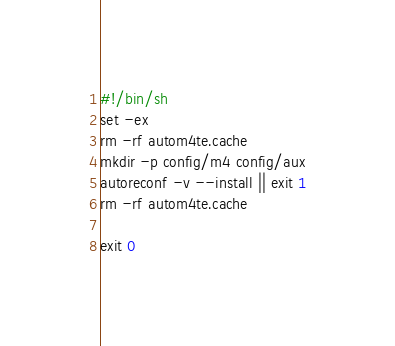<code> <loc_0><loc_0><loc_500><loc_500><_Bash_>#!/bin/sh
set -ex
rm -rf autom4te.cache
mkdir -p config/m4 config/aux
autoreconf -v --install || exit 1
rm -rf autom4te.cache
 
exit 0
</code> 